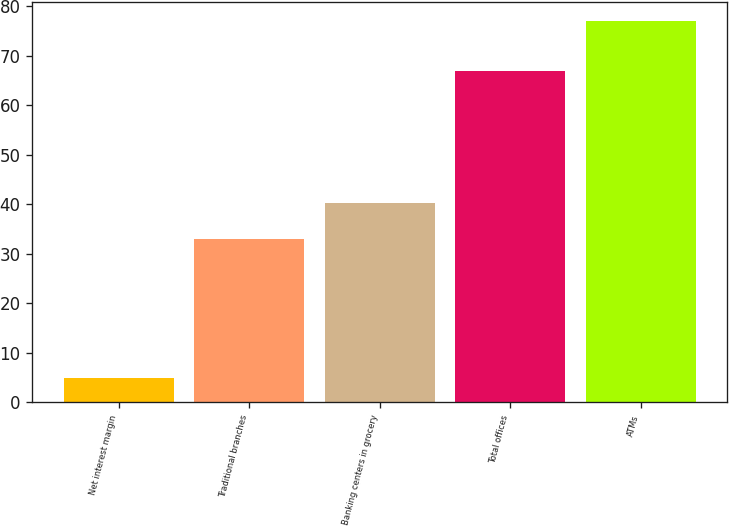<chart> <loc_0><loc_0><loc_500><loc_500><bar_chart><fcel>Net interest margin<fcel>Traditional branches<fcel>Banking centers in grocery<fcel>Total offices<fcel>ATMs<nl><fcel>4.94<fcel>33<fcel>40.21<fcel>67<fcel>77<nl></chart> 